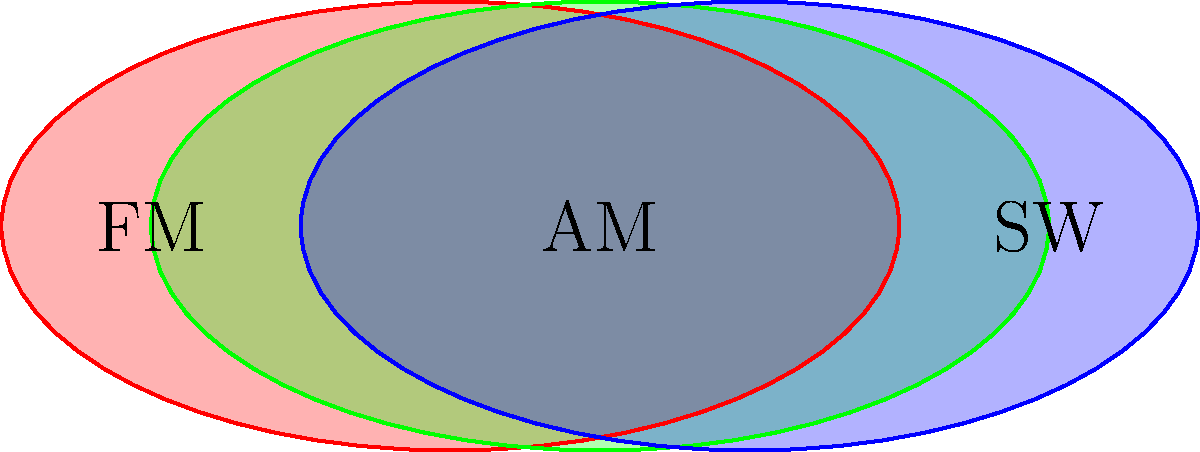In the topological representation of overlapping radio frequency bands shown above, how many distinct regions are created by the intersection of FM, AM, and SW bands? To determine the number of distinct regions created by the overlapping radio frequency bands, we need to follow these steps:

1. Identify the individual bands: FM (red), AM (green), and SW (blue).

2. Analyze the intersections:
   a. FM ∩ AM (red and green overlap)
   b. AM ∩ SW (green and blue overlap)
   c. FM ∩ SW (red and blue overlap)
   d. FM ∩ AM ∩ SW (all three overlap)

3. Count the distinct regions:
   - FM only (leftmost red area)
   - AM only (central green area)
   - SW only (rightmost blue area)
   - FM ∩ AM (left red-green overlap)
   - AM ∩ SW (right green-blue overlap)
   - FM ∩ SW (there is no direct red-blue overlap)
   - FM ∩ AM ∩ SW (central overlap of all three colors)

4. Sum up the total number of distinct regions: 7

This topological representation demonstrates the complexity of managing radio frequency allocations in a crowded spectrum, where different bands may overlap and interfere with each other.
Answer: 7 distinct regions 